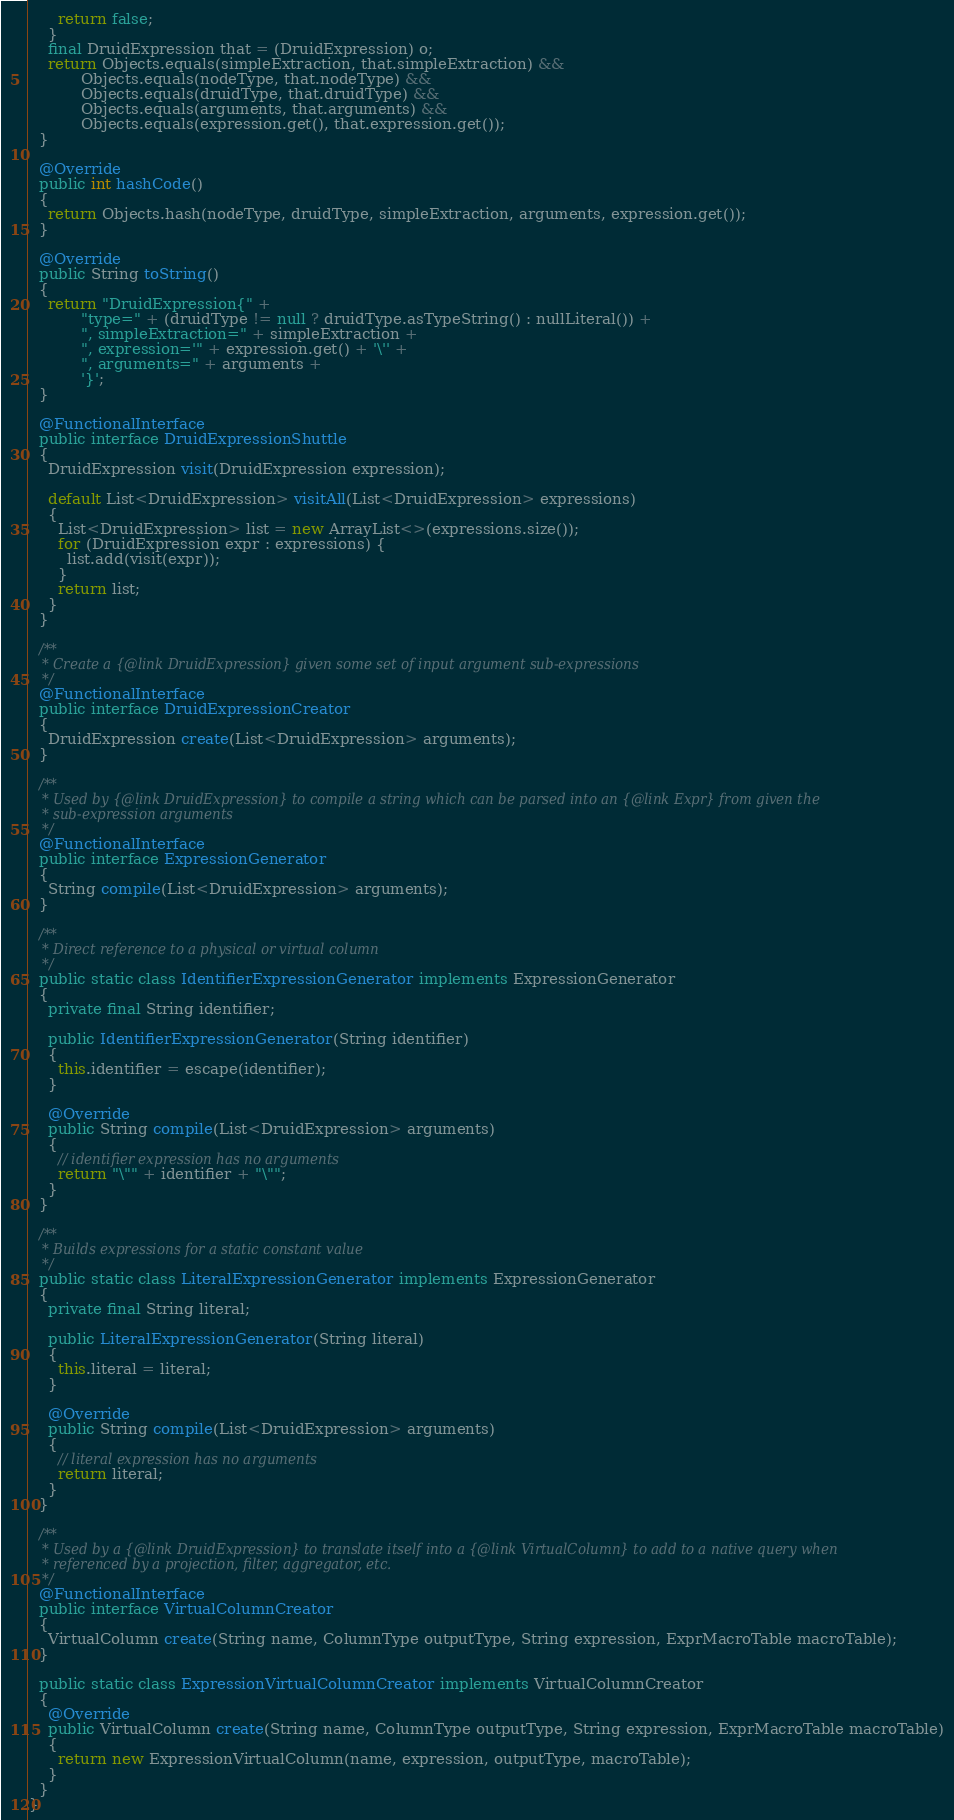Convert code to text. <code><loc_0><loc_0><loc_500><loc_500><_Java_>      return false;
    }
    final DruidExpression that = (DruidExpression) o;
    return Objects.equals(simpleExtraction, that.simpleExtraction) &&
           Objects.equals(nodeType, that.nodeType) &&
           Objects.equals(druidType, that.druidType) &&
           Objects.equals(arguments, that.arguments) &&
           Objects.equals(expression.get(), that.expression.get());
  }

  @Override
  public int hashCode()
  {
    return Objects.hash(nodeType, druidType, simpleExtraction, arguments, expression.get());
  }

  @Override
  public String toString()
  {
    return "DruidExpression{" +
           "type=" + (druidType != null ? druidType.asTypeString() : nullLiteral()) +
           ", simpleExtraction=" + simpleExtraction +
           ", expression='" + expression.get() + '\'' +
           ", arguments=" + arguments +
           '}';
  }

  @FunctionalInterface
  public interface DruidExpressionShuttle
  {
    DruidExpression visit(DruidExpression expression);

    default List<DruidExpression> visitAll(List<DruidExpression> expressions)
    {
      List<DruidExpression> list = new ArrayList<>(expressions.size());
      for (DruidExpression expr : expressions) {
        list.add(visit(expr));
      }
      return list;
    }
  }

  /**
   * Create a {@link DruidExpression} given some set of input argument sub-expressions
   */
  @FunctionalInterface
  public interface DruidExpressionCreator
  {
    DruidExpression create(List<DruidExpression> arguments);
  }

  /**
   * Used by {@link DruidExpression} to compile a string which can be parsed into an {@link Expr} from given the
   * sub-expression arguments
   */
  @FunctionalInterface
  public interface ExpressionGenerator
  {
    String compile(List<DruidExpression> arguments);
  }

  /**
   * Direct reference to a physical or virtual column
   */
  public static class IdentifierExpressionGenerator implements ExpressionGenerator
  {
    private final String identifier;

    public IdentifierExpressionGenerator(String identifier)
    {
      this.identifier = escape(identifier);
    }

    @Override
    public String compile(List<DruidExpression> arguments)
    {
      // identifier expression has no arguments
      return "\"" + identifier + "\"";
    }
  }

  /**
   * Builds expressions for a static constant value
   */
  public static class LiteralExpressionGenerator implements ExpressionGenerator
  {
    private final String literal;

    public LiteralExpressionGenerator(String literal)
    {
      this.literal = literal;
    }

    @Override
    public String compile(List<DruidExpression> arguments)
    {
      // literal expression has no arguments
      return literal;
    }
  }

  /**
   * Used by a {@link DruidExpression} to translate itself into a {@link VirtualColumn} to add to a native query when
   * referenced by a projection, filter, aggregator, etc.
   */
  @FunctionalInterface
  public interface VirtualColumnCreator
  {
    VirtualColumn create(String name, ColumnType outputType, String expression, ExprMacroTable macroTable);
  }

  public static class ExpressionVirtualColumnCreator implements VirtualColumnCreator
  {
    @Override
    public VirtualColumn create(String name, ColumnType outputType, String expression, ExprMacroTable macroTable)
    {
      return new ExpressionVirtualColumn(name, expression, outputType, macroTable);
    }
  }
}
</code> 